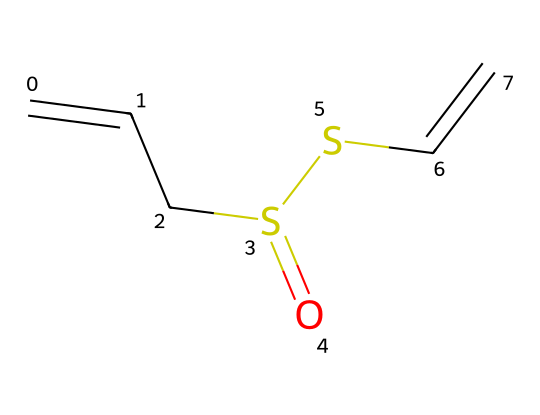What is the total number of carbon atoms in allicin? In the provided SMILES representation, we can identify the number of carbon atoms by counting the ‘C’ occurrences. There are four 'C's present in the structure.
Answer: four How many sulfur atoms are in allicin? By examining the SMILES string, we can see two occurrences of the 'S' which indicates the presence of two sulfur atoms in the structure.
Answer: two What functional groups are present in allicin? The structure contains a thioether functionality due to the presence of sulfur atoms connected to carbon atoms, and it also exhibits an alkene due to C=C bonds. Therefore, the functional groups are thioether and alkene.
Answer: thioether and alkene What is the overall molecular formula of allicin? To determine the molecular formula, we combine the counts of carbon (C), hydrogen (H), oxygen (O), and sulfur (S) based on their occurrences in the structure. The overall count yields a molecular formula of C6H10S2.
Answer: C6H10S2 How many unique elements are present in allicin? By analyzing the structure, we identify that allicin is comprised of four distinct elements: carbon (C), hydrogen (H), sulfur (S), and oxygen (O).
Answer: four What type of compound is allicin classified as? Given the presence of sulfur atoms in its structure, allicin is classified as an organosulfur compound.
Answer: organosulfur compound What type of bond is present between the carbon atoms in the allicin structure? The presence of 'C=C' in the SMILES notation indicates that there are double bonds between certain carbon atoms, characterizing them as alkenes.
Answer: double bond 